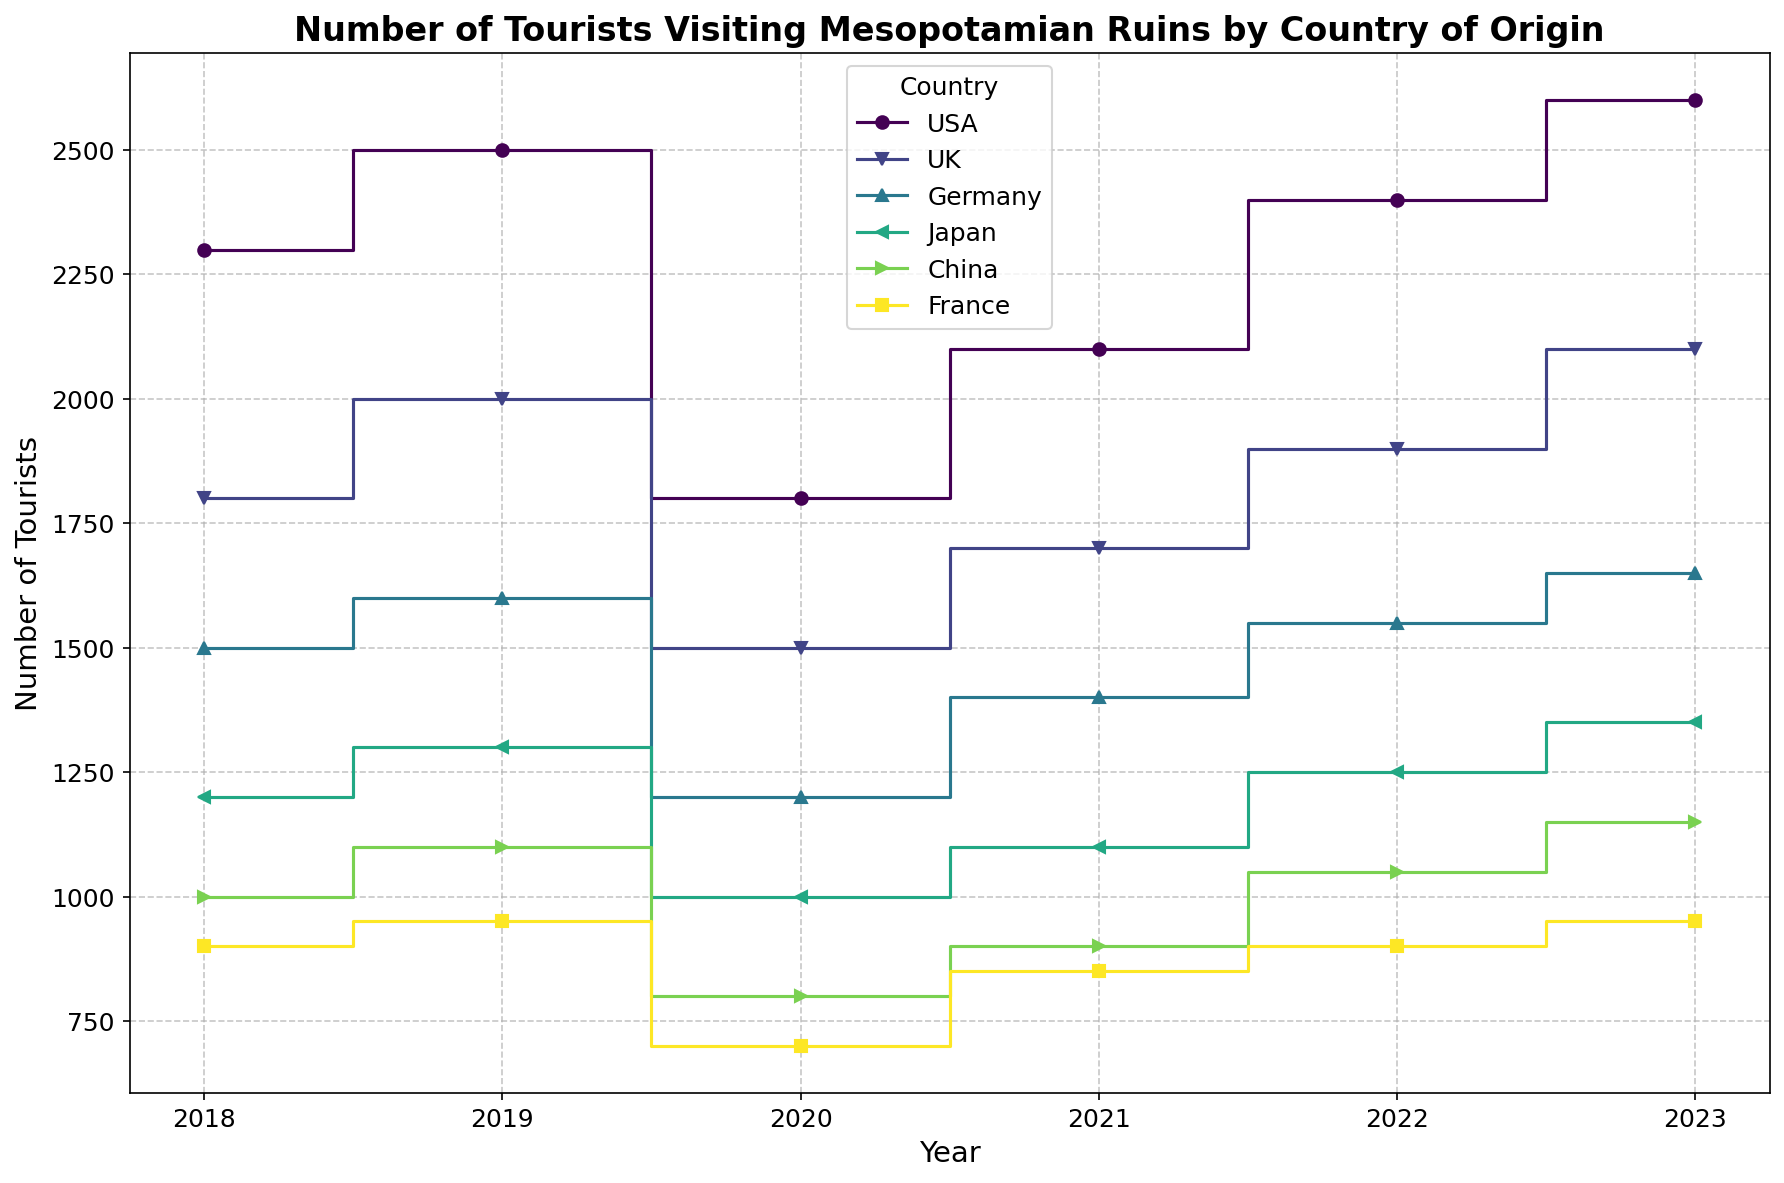What's the trend of the number of tourists from the USA from 2018 to 2023? To determine the trend, look at the height of the steps representing the USA for each year. The steps show an increase from 2300 in 2018 to 2500 in 2019, a drop to 1800 in 2020, an increase again to 2100 in 2021, and further increases to 2400 in 2022 and 2600 in 2023. Overall, the trend is upward.
Answer: Upward Which country had the least number of tourists in 2020? Examine the height of the steps for each country in 2020. The shortest bar represents France, with 700 tourists.
Answer: France In which year did the UK see the highest number of tourists visiting Mesopotamian ruins? Look at the heights of the steps for the UK across all years. The highest step occurs in 2023 with 2100 tourists.
Answer: 2023 What is the average annual number of tourists from Japan from 2018 to 2023? Sum the number of tourists from Japan for each year (1200, 1300, 1000, 1100, 1250, 1350) and then divide by the number of years (6). The calculation is (1200 + 1300 + 1000 + 1100 + 1250 + 1350) / 6.
Answer: 1200 Compare the number of tourists from Germany and China in 2023. Which country had more tourists, and by how much? Check the steps for Germany and China in 2023. Germany had 1650 tourists, and China had 1150 tourists. The difference is 1650 - 1150.
Answer: Germany, by 500 tourists Has the number of tourists from France ever exceeded 1000 in any year from 2018 to 2023? Review the height of the steps representing France each year. None of the steps for France cross the 1000 mark.
Answer: No Which country showed a consistent increase in the number of tourists every year from 2018 to 2023? Check the trend for each country. The steps for China show a consistent increase from 1000 in 2018 to 1150 in 2023.
Answer: China What is the combined number of tourists from the USA and the UK in 2019? Sum the number of tourists from the USA and the UK in 2019 (2500 + 2000). The calculation is 2500 + 2000.
Answer: 4500 Which year had the highest total number of tourists across all countries? Combine the number of tourists for all countries in each year and compare the totals: 2018 (8700), 2019 (9450), 2020 (7000), 2021 (8050), 2022 (9050), 2023 (9800).
Answer: 2023 